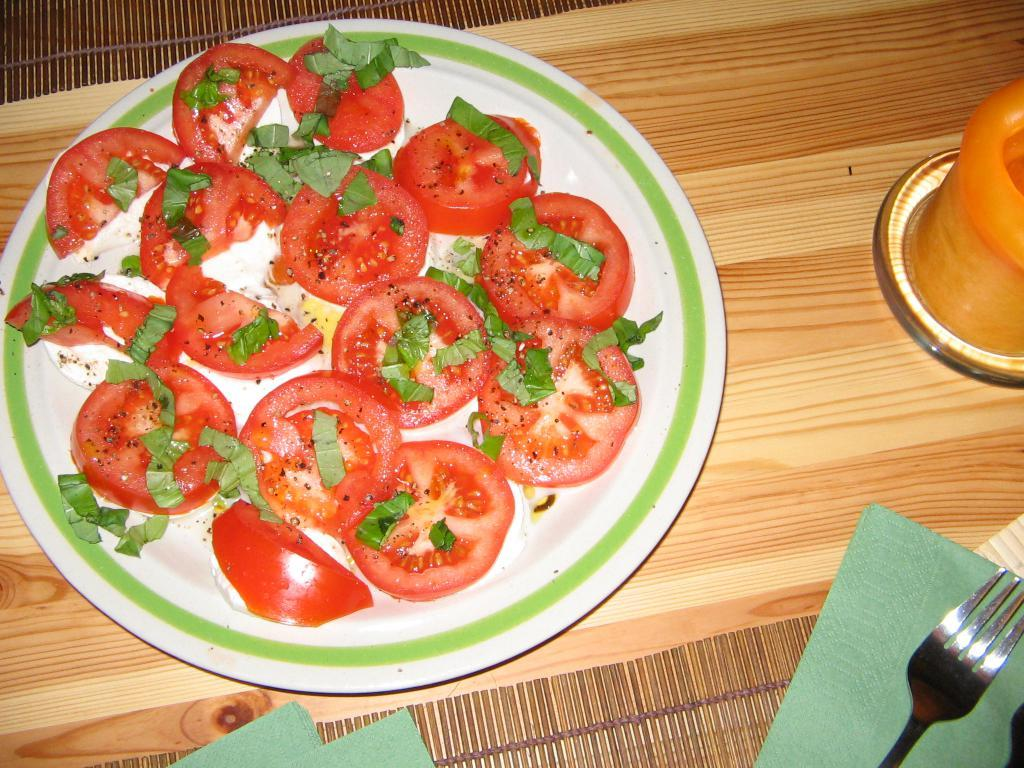What type of food can be seen in the image? There are sliced tomatoes in the image. What else is present in the image that might be used for a salad? There is salad topping in the image. Where are the tomatoes and salad topping located? They are in a plate in the image. What surface is the plate resting on? The plate is on a table in the image. What might be used for wiping or drying in the image? Napkins are present in the image. What utensils can be seen in the image? There are forks in the image. What type of jar is visible in the image? There is no jar present in the image. What activity is the cap performing in the image? There is no cap present in the image, so it cannot be performing any activity. 